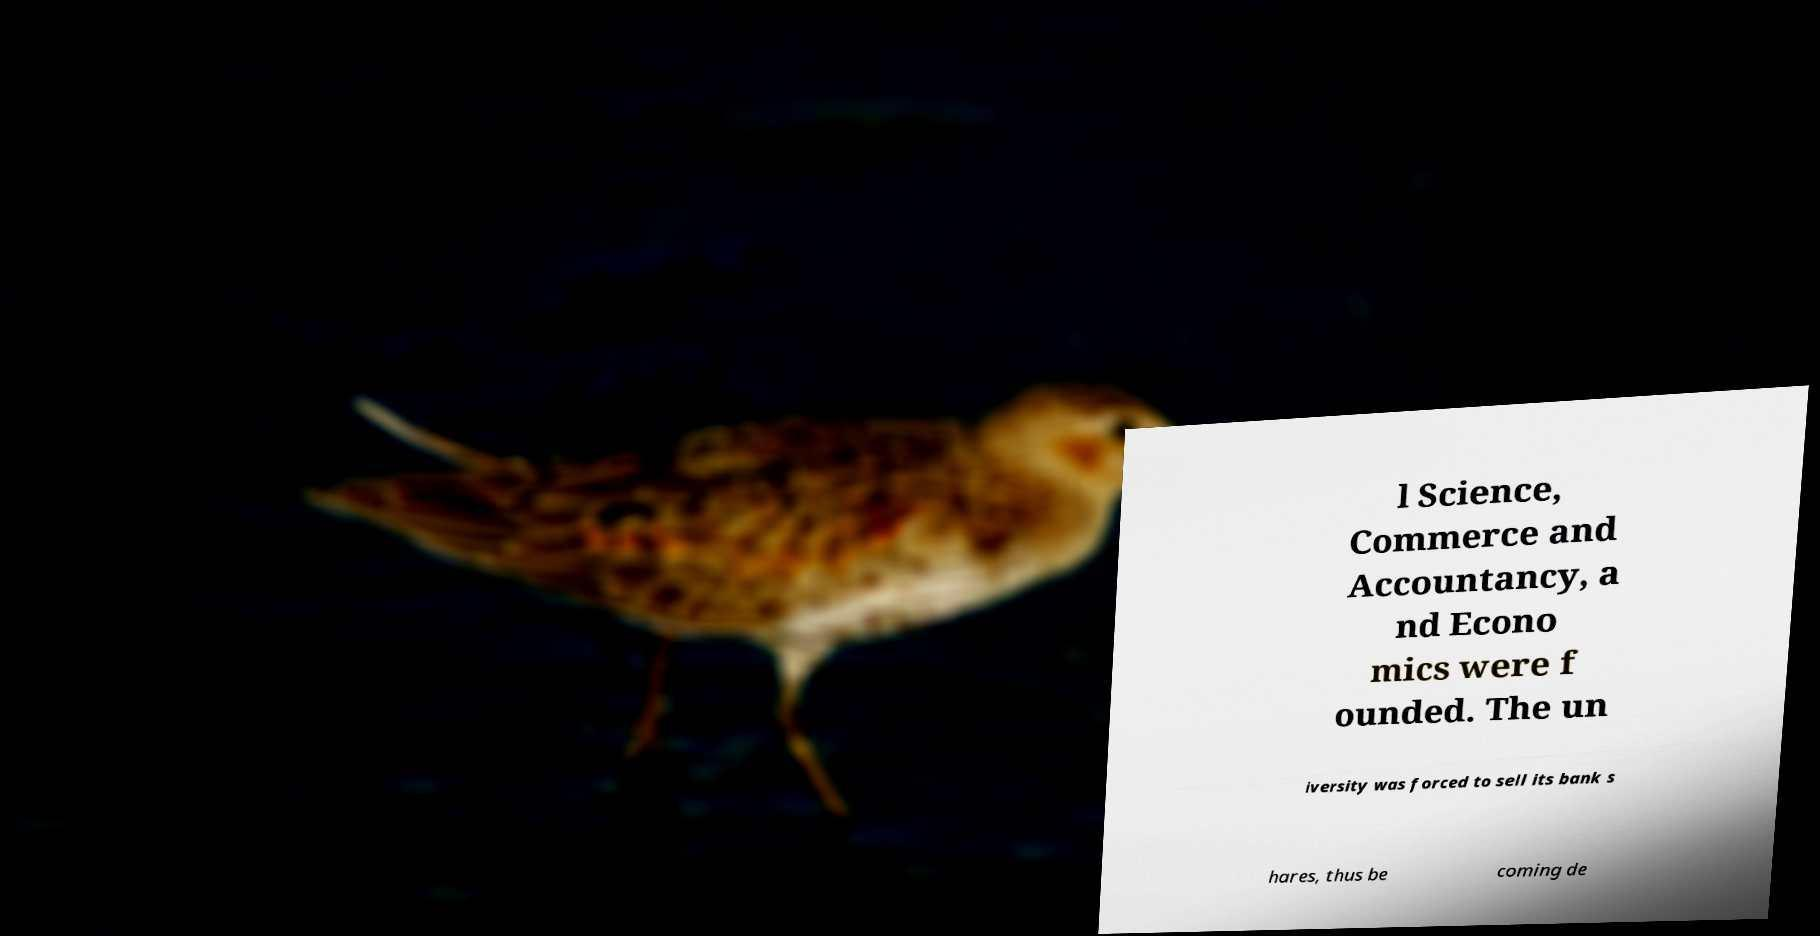For documentation purposes, I need the text within this image transcribed. Could you provide that? l Science, Commerce and Accountancy, a nd Econo mics were f ounded. The un iversity was forced to sell its bank s hares, thus be coming de 